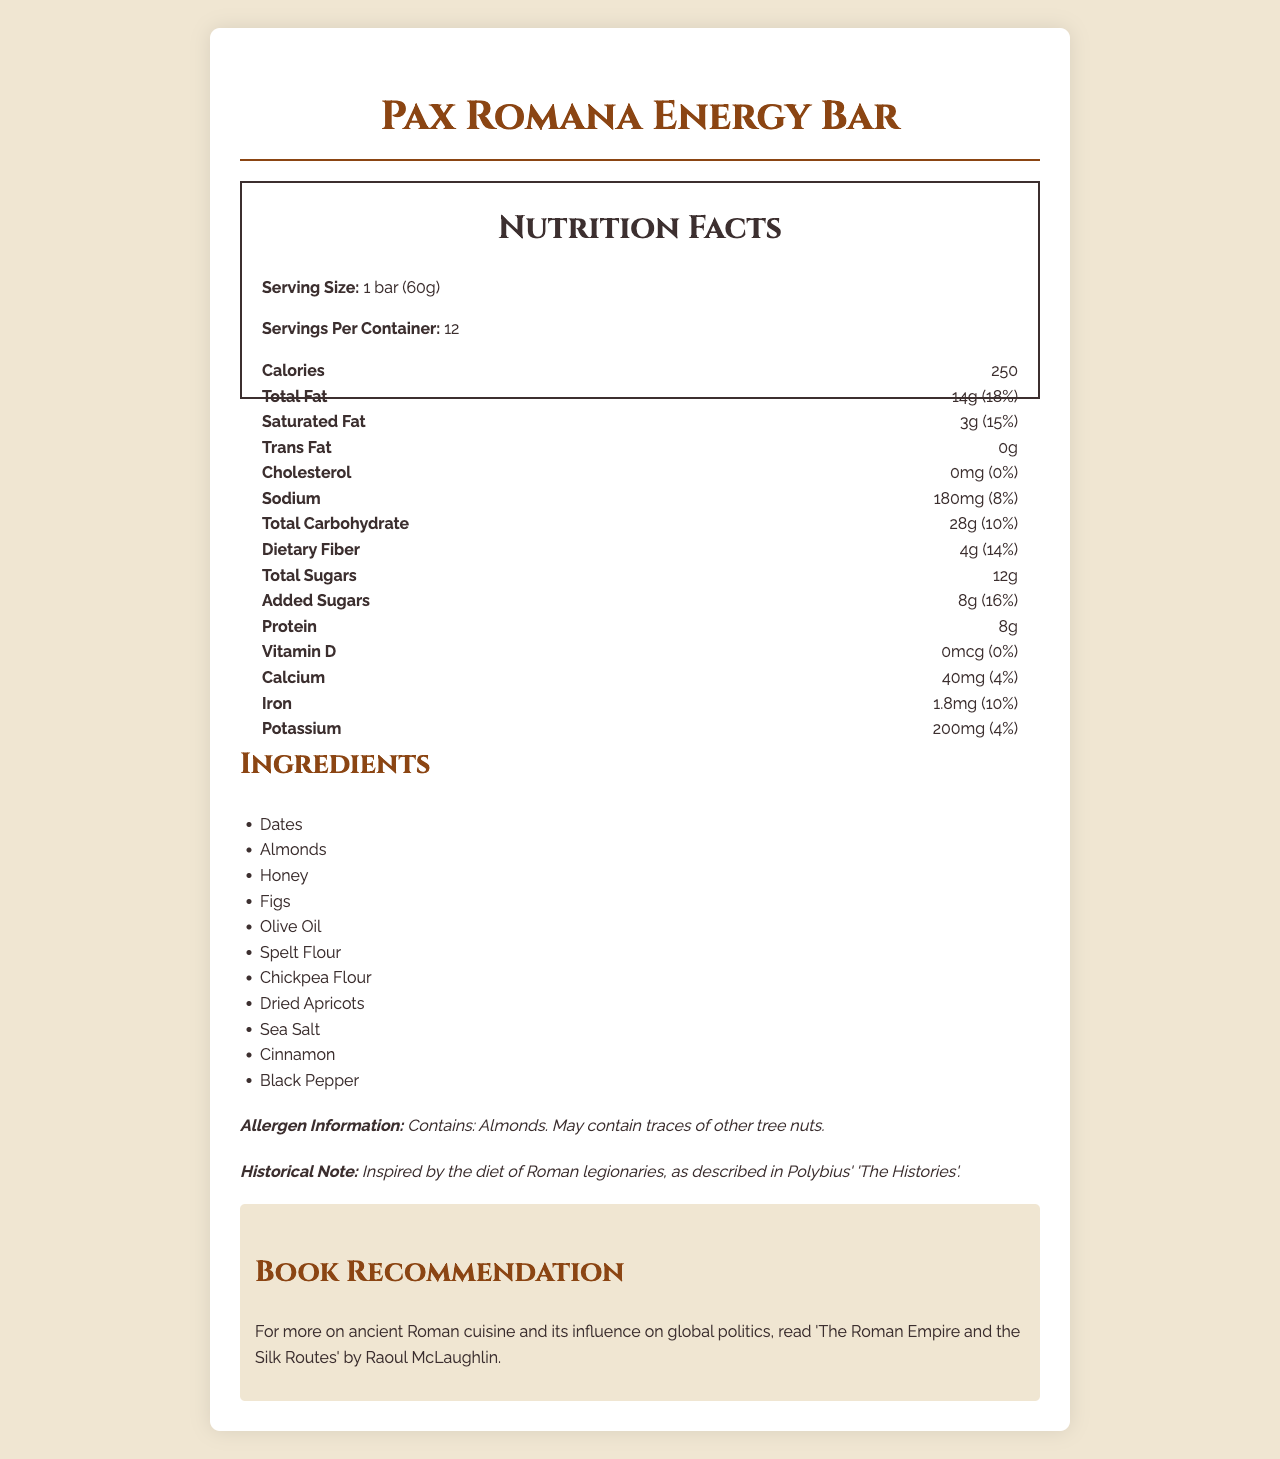what is the serving size of the Pax Romana Energy Bar? The serving size is explicitly mentioned under the "Nutrition Facts" section as "1 bar (60g)".
Answer: 1 bar (60g) how many servings are there per container? The document states that there are 12 servings per container.
Answer: 12 how many calories are in one serving of the Pax Romana Energy Bar? The number of calories per serving is listed under the "Nutrition Facts" section as 250.
Answer: 250 what is the total amount of fat in one serving of the energy bar? The total fat per serving is given as 14g in the "Nutrition Facts" section.
Answer: 14g how much sodium does one serving contain? One serving contains 180mg of sodium, as outlined under "Nutrition Facts".
Answer: 180mg how much protein is in each Pax Romana Energy Bar? A. 6g B. 7g C. 8g D. 9g The "Nutrition Facts" section lists the protein content per serving as 8g.
Answer: C. 8g which ingredient is the main source of dietary fiber in the energy bar? A. Almonds B. Dates C. Chickpea Flour D. Figs Chickpea flour is known to be a good source of dietary fiber, and it is included in the ingredients list.
Answer: C. Chickpea Flour does the energy bar contain any trans fat? The "Nutrition Facts" section specifies that the amount of trans fat in one serving is 0g.
Answer: No is there any cholesterol in the Pax Romana Energy Bar? The "Nutrition Facts" section indicates that there is 0mg of cholesterol per serving.
Answer: No summarize the document's key points regarding the Pax Romana Energy Bar. The document format is typical for nutritional labels and aims to provide a comprehensive overview of the energy bar's nutritional value, ingredients, and historical inspiration.
Answer: The document is a nutritional information label for the Pax Romana Energy Bar, inspired by ancient Roman cuisine. It provides details on serving size, servings per container, calorie content, as well as individual nutrient amounts like fats, sodium, carbohydrates, and proteins. It also lists the ingredients, allergen information, a historical note, and offers a book recommendation on ancient Roman cuisine. what is the historical inspiration for the Pax Romana Energy Bar? The historical inspiration is explicitly mentioned in the historical note: "Inspired by the diet of Roman legionaries, as described in Polybius' 'The Histories'."
Answer: The diet of Roman legionaries as described in Polybius' 'The Histories' how much added sugars are in one serving of the energy bar? One serving of the energy bar contains 8g of added sugars, as shown in the "Nutrition Facts" section.
Answer: 8g which vitamin is missing from the energy bar? A. Vitamin A B. Vitamin C C. Vitamin D D. Vitamin B12 The "Nutrition Facts" section specifies that there is 0mcg of Vitamin D, meaning it is missing from the energy bar.
Answer: C. Vitamin D can you determine the exact percentage of the daily value for potassium in the energy bar? The amount of potassium is listed as 200mg, which corresponds to 4% of the daily value, as indicated in the "Nutrition Facts" section.
Answer: Yes which tree nut is listed as an allergen in the ingredients? The allergen information specifies that the bar contains almonds and may contain traces of other tree nuts.
Answer: Almonds what is the main purpose of the book recommendation? The book recommendation is meant to provide further context and depth on the historical inspiration behind the energy bar by suggesting the book "The Roman Empire and the Silk Routes" by Raoul McLaughlin.
Answer: To offer additional reading on ancient Roman cuisine and its influence on global politics what is the total amount of sugars in one bar of the Pax Romana Energy Bar? The total sugars per serving are listed as 12g in the "Nutrition Facts" section.
Answer: 12g who is the author of the recommended book on ancient Roman cuisine? The recommended book "The Roman Empire and the Silk Routes" is written by Raoul McLaughlin, as stated in the book recommendation section.
Answer: Raoul McLaughlin how many calories are there in two servings of the Pax Romana Energy Bar? Since one serving has 250 calories, two servings would have 250 * 2 = 500 calories.
Answer: 500 what percentage of the daily value of dietary fiber does one serving of the energy bar provide? One serving of the energy bar provides 14% of the daily value for dietary fiber, as listed in the "Nutrition Facts" section.
Answer: 14% what is the source of this phrase: "Inspired by the diet of Roman legionaries, as described in Polybius' 'The Histories'"? This information is stated under the "Historical Note" section in the document.
Answer: Historical note 